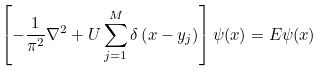Convert formula to latex. <formula><loc_0><loc_0><loc_500><loc_500>\left [ - \frac { 1 } { \pi ^ { 2 } } \nabla ^ { 2 } + U \sum _ { j = 1 } ^ { M } \delta \left ( x - y _ { j } \right ) \right ] \psi ( x ) = E \psi ( x )</formula> 